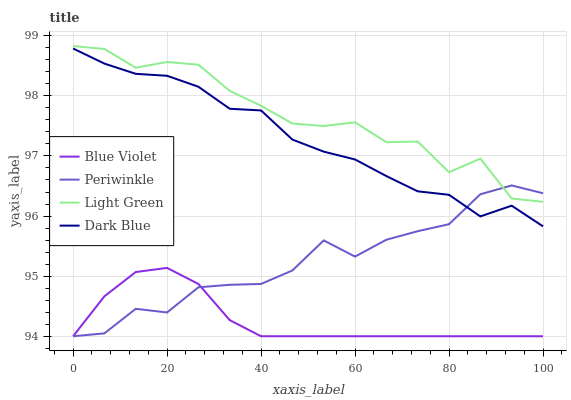Does Blue Violet have the minimum area under the curve?
Answer yes or no. Yes. Does Light Green have the maximum area under the curve?
Answer yes or no. Yes. Does Periwinkle have the minimum area under the curve?
Answer yes or no. No. Does Periwinkle have the maximum area under the curve?
Answer yes or no. No. Is Blue Violet the smoothest?
Answer yes or no. Yes. Is Light Green the roughest?
Answer yes or no. Yes. Is Periwinkle the smoothest?
Answer yes or no. No. Is Periwinkle the roughest?
Answer yes or no. No. Does Periwinkle have the lowest value?
Answer yes or no. Yes. Does Light Green have the lowest value?
Answer yes or no. No. Does Light Green have the highest value?
Answer yes or no. Yes. Does Periwinkle have the highest value?
Answer yes or no. No. Is Blue Violet less than Light Green?
Answer yes or no. Yes. Is Light Green greater than Dark Blue?
Answer yes or no. Yes. Does Light Green intersect Periwinkle?
Answer yes or no. Yes. Is Light Green less than Periwinkle?
Answer yes or no. No. Is Light Green greater than Periwinkle?
Answer yes or no. No. Does Blue Violet intersect Light Green?
Answer yes or no. No. 